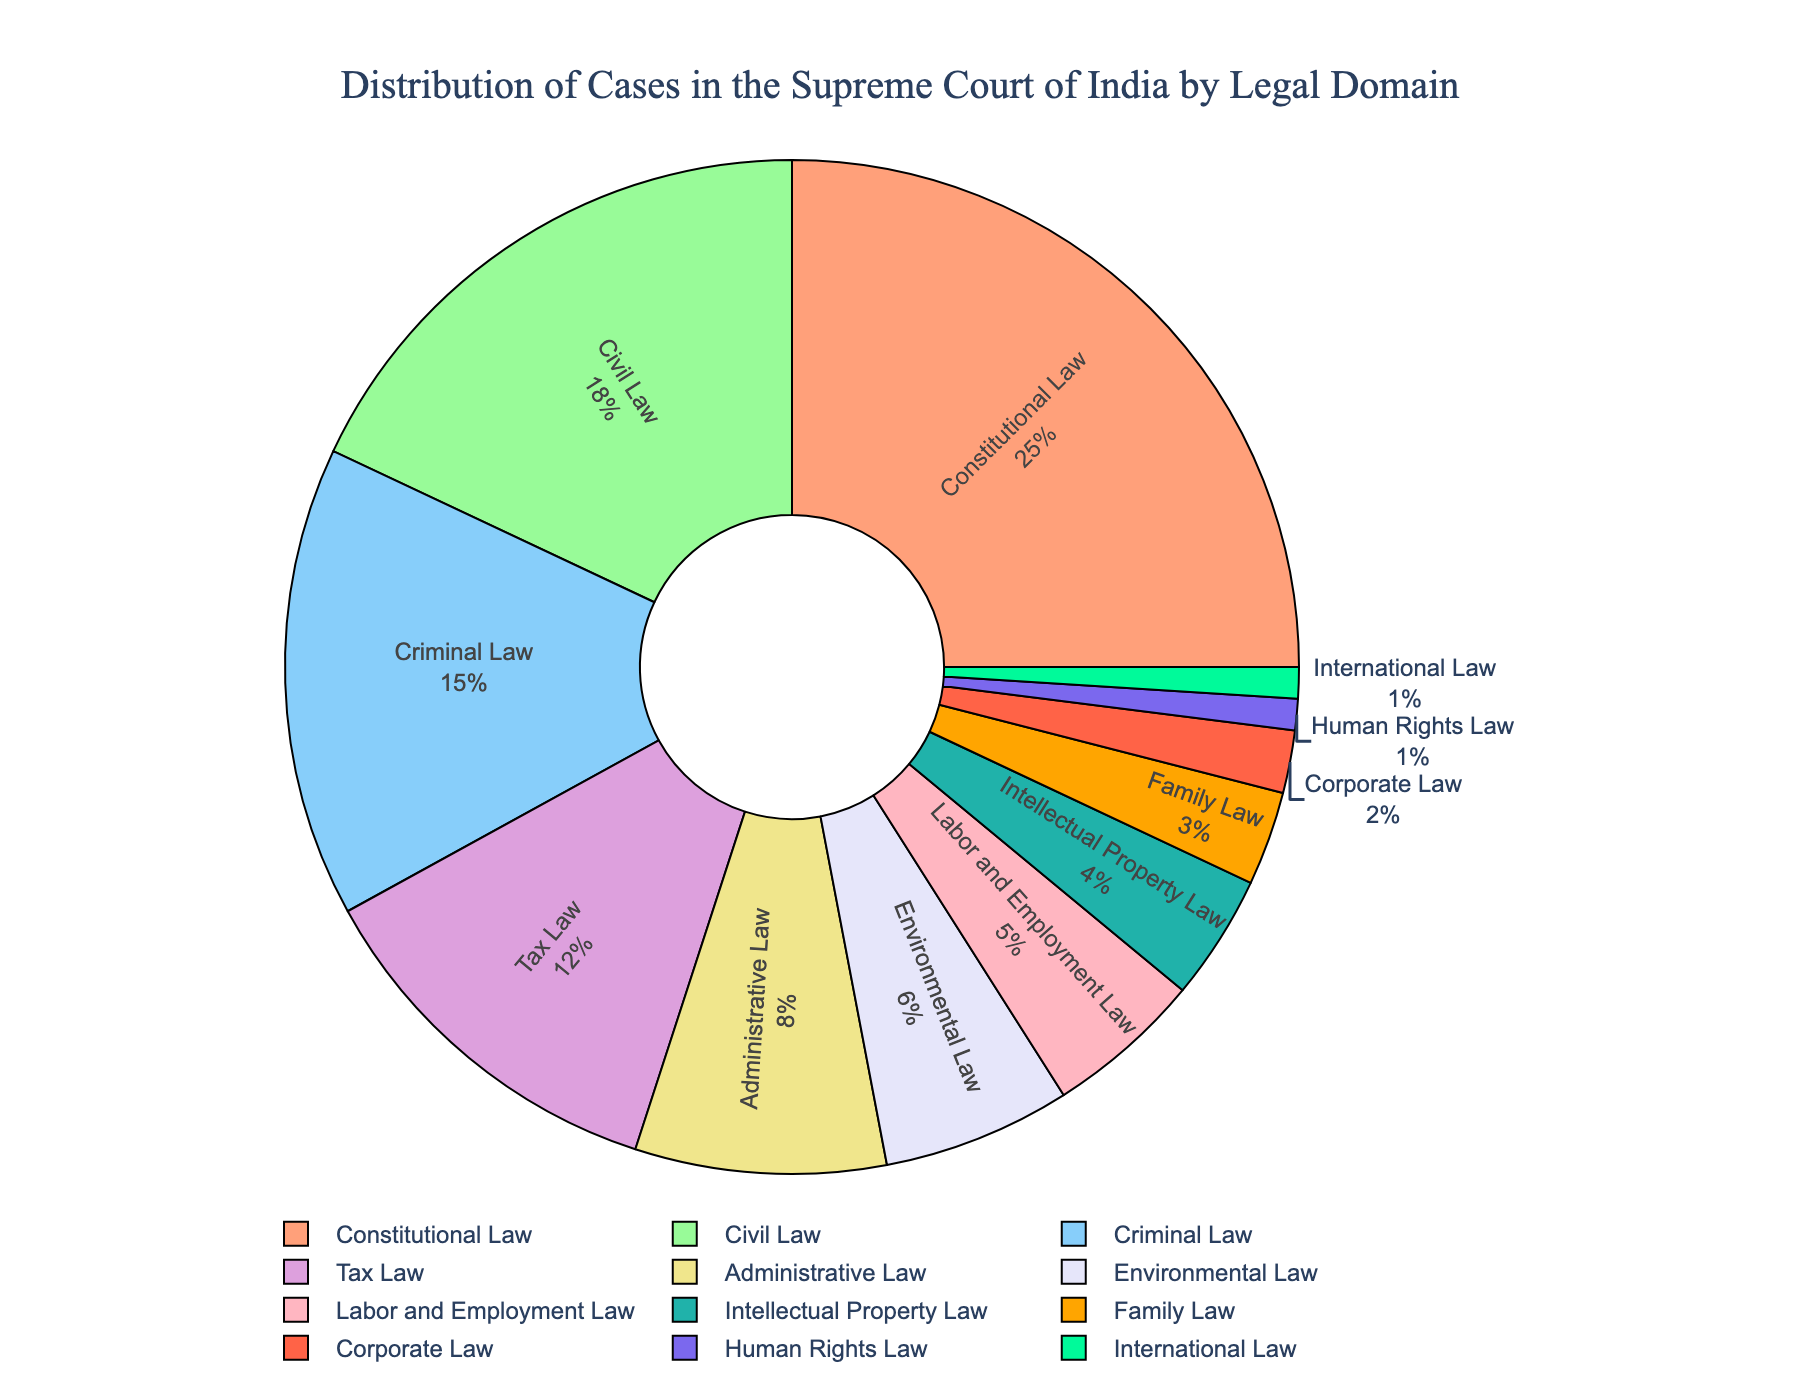Which legal domain has the highest percentage of cases? The largest segment in the pie chart represents Constitutional Law, indicating it has the highest percentage of cases at 25%.
Answer: Constitutional Law If you combine the percentages for Civil Law and Criminal Law, what is the total? Civil Law has 18% and Criminal Law has 15%. Adding these together gives: 18% + 15% = 33%.
Answer: 33% Which legal domain has a smaller percentage of cases, Environmental Law or Tax Law? The pie chart shows that Environmental Law has 6% and Tax Law has 12%, so Environmental Law has a smaller percentage.
Answer: Environmental Law How many legal domains have a percentage of cases less than 5%? The legal domains with less than 5% are: Intellectual Property Law (4%), Family Law (3%), Corporate Law (2%), Human Rights Law (1%), and International Law (1%). There are 5 legal domains in total.
Answer: 5 What's the combined percentage for the legal domains related to economic matters (Tax Law, Corporate Law, and Labor and Employment Law)? Tax Law has 12%, Corporate Law has 2%, and Labor and Employment Law has 5%. Adding these together gives: 12% + 2% + 5% = 19%.
Answer: 19% What is the percentage difference between Constitutional Law and Administrative Law? Constitutional Law has 25% and Administrative Law has 8%, so the difference is: 25% - 8% = 17%.
Answer: 17% Which legal domain has the least percentage of cases, and what is it? The pie chart shows that both Human Rights Law and International Law have the lowest percentage, each at 1%.
Answer: Human Rights Law and International Law (1%) By how much does the percentage of cases in Civil Law exceed that in Labor and Employment Law? Civil Law has 18% and Labor and Employment Law has 5%, so the excess is: 18% - 5% = 13%.
Answer: 13% What is the average percentage of cases for Administrative Law, Environmental Law, and Family Law? The percentages are: Administrative Law (8%), Environmental Law (6%), and Family Law (3%). The average is calculated as: (8% + 6% + 3%) / 3 = 17% / 3 ≈ 5.67%.
Answer: 5.67% What is the percentage gap between the legal domain with the maximum and the one with the minimum percentage of cases? The legal domain with the maximum percentage is Constitutional Law (25%) and the ones with the minimum are Human Rights Law and International Law (1%). The gap is: 25% - 1% = 24%.
Answer: 24% 